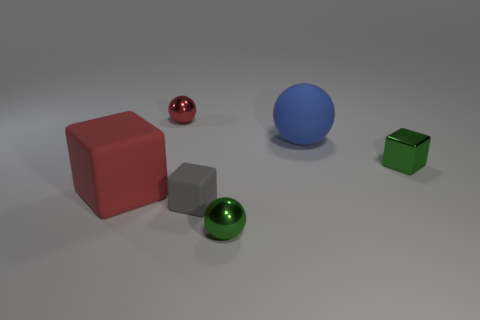There is a small object that is the same color as the tiny metal cube; what shape is it?
Provide a short and direct response. Sphere. Are there the same number of red things that are in front of the green block and green cubes in front of the big red cube?
Offer a very short reply. No. The small metal object that is the same shape as the big red matte thing is what color?
Give a very brief answer. Green. Is there any other thing that is the same shape as the red shiny thing?
Your response must be concise. Yes. There is a tiny block behind the big matte cube; does it have the same color as the large matte ball?
Your response must be concise. No. There is a green metallic thing that is the same shape as the tiny gray thing; what is its size?
Give a very brief answer. Small. What number of large red blocks have the same material as the gray cube?
Offer a very short reply. 1. There is a tiny green object behind the tiny metal sphere that is in front of the large red thing; is there a red object in front of it?
Your answer should be very brief. Yes. What is the shape of the big red rubber thing?
Give a very brief answer. Cube. Does the large object that is behind the big red thing have the same material as the cube right of the small green ball?
Your answer should be compact. No. 